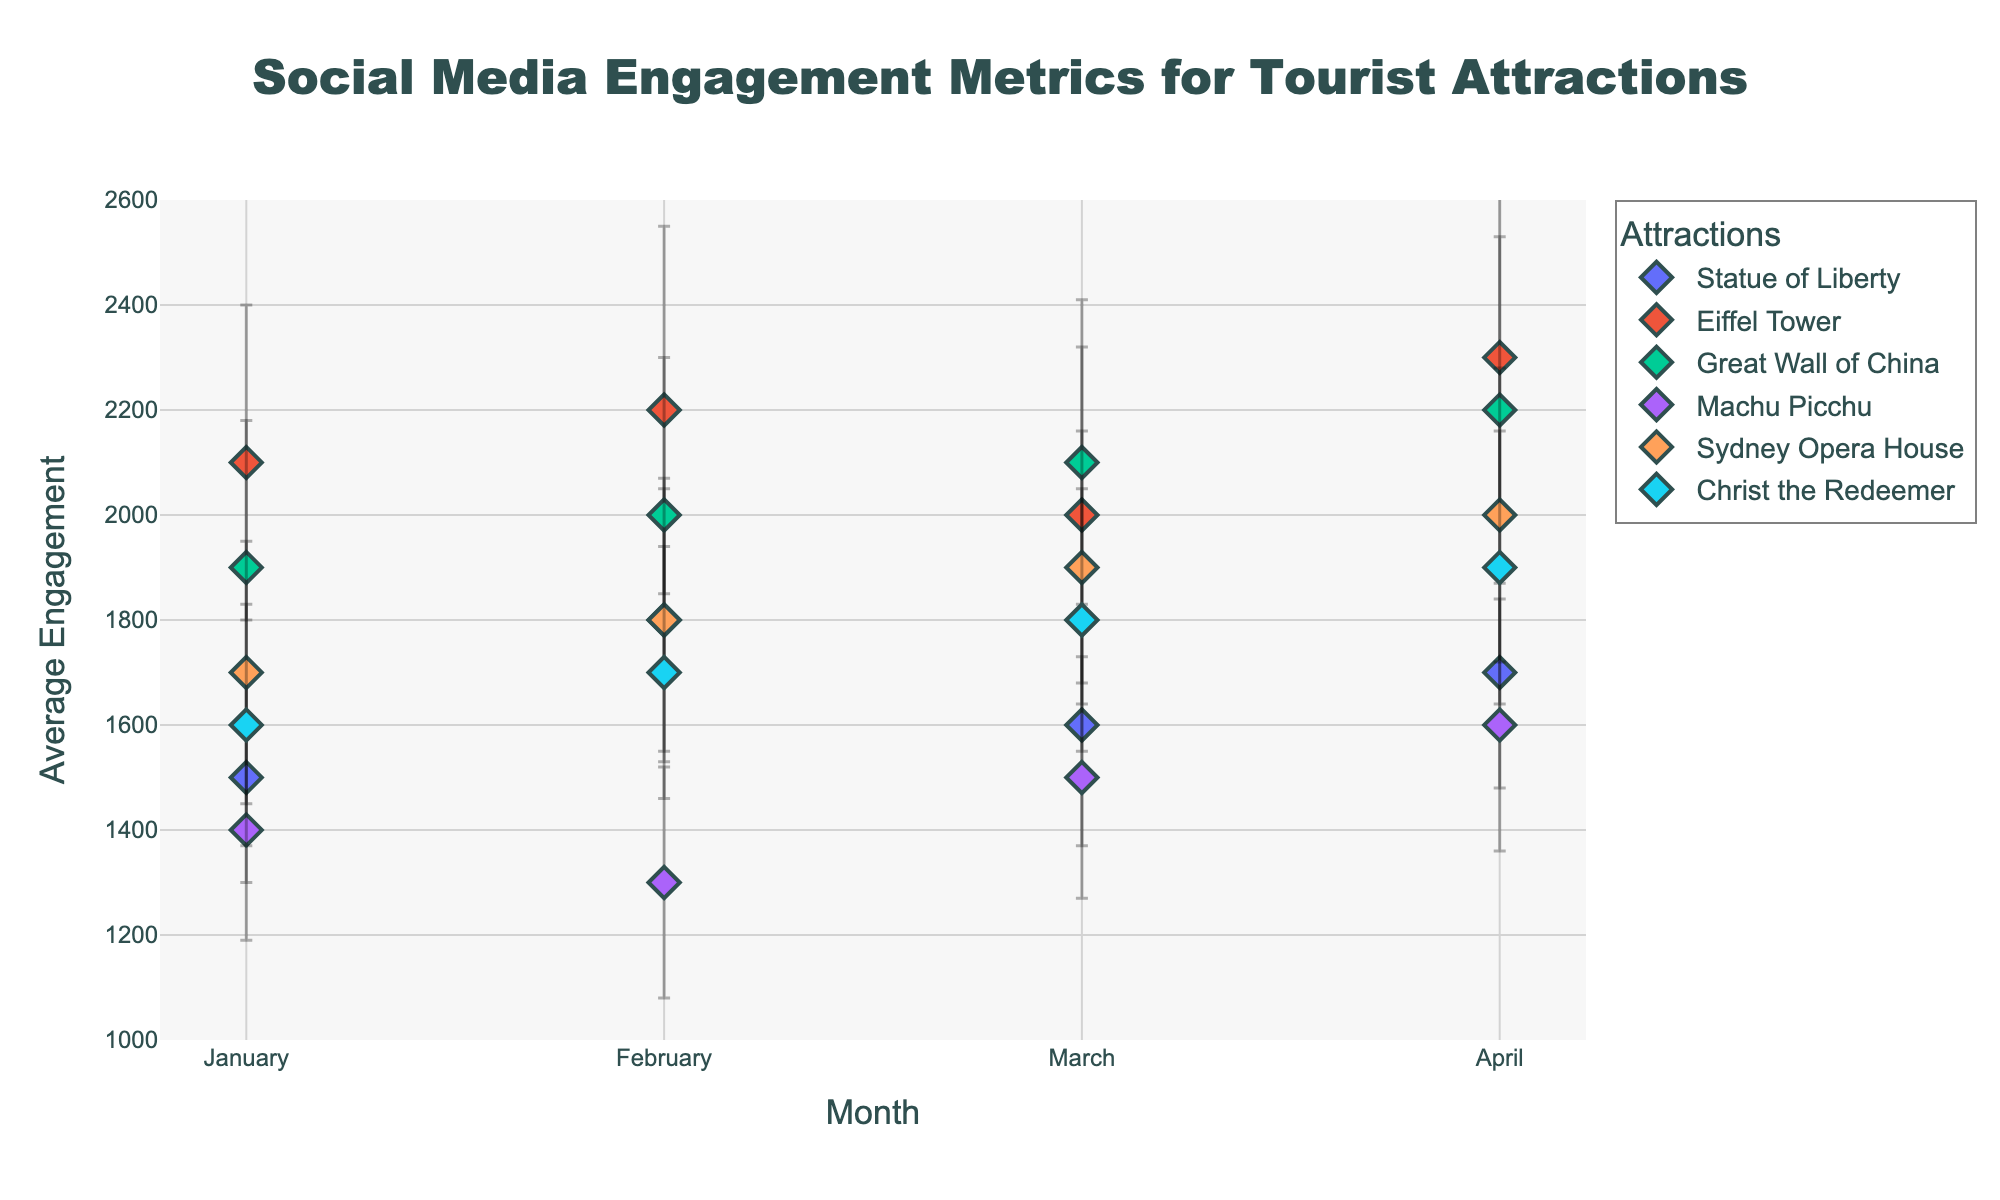what is the title of the figure? The title of the figure is found at the top of the plot and provides a summary of the content displayed. In this case, the title indicates the main subject of the visualization.
Answer: Social Media Engagement Metrics for Tourist Attractions How many attractions are being compared in the plot? To determine the number of attractions, one can count the distinct legend entries that represent each attraction plotted.
Answer: 6 Which attraction has the highest average engagement in April? By examining the markers along the y-axis for the month of April, the engagement with the highest point corresponds to the attraction with the greatest average engagement.
Answer: Eiffel Tower What is the difference in average engagement between the Eiffel Tower and Machu Picchu in February? Locate the average engagement points for both the Eiffel Tower and Machu Picchu in February and subtract the latter from the former to find the difference.
Answer: 900 Which month shows the highest variability in average engagement for the Great Wall of China? Compare the lengths of the error bars for each month relating to the Great Wall of China to identify which month has the largest error bar.
Answer: April What is the overall trend in average engagement for the Sydney Opera House from January to April? Observe the markers representing the Sydney Opera House and look at their sequential positions from January to April along the y-axis to identify any trend.
Answer: Increasing Which attraction shows the least change in average engagement from January to April? For each attraction, compare the markers from January to April, and identify the one with the smallest overall movement in engagement values across the months.
Answer: Christ the Redeemer Is there any month where Statue of Liberty has higher average engagement than Sydney Opera House? Compare the average engagement values for Statue of Liberty and Sydney Opera House month by month to see if there are any instances where the Statue of Liberty’s value is higher.
Answer: No What is the average engagement of Machu Picchu in January with its error margin? Locate Machu Picchu’s engagement in January and add/subtract the error margin to provide the range.
Answer: 1400 ± 210 Which two attractions have the closest average engagement in March? Compare the average engagement values for all attractions in March and find the pair with the smallest difference.
Answer: Great Wall of China and Eiffel Tower 